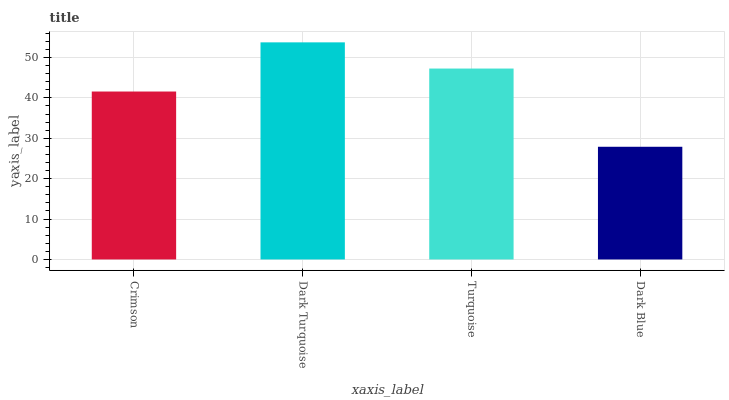Is Dark Blue the minimum?
Answer yes or no. Yes. Is Dark Turquoise the maximum?
Answer yes or no. Yes. Is Turquoise the minimum?
Answer yes or no. No. Is Turquoise the maximum?
Answer yes or no. No. Is Dark Turquoise greater than Turquoise?
Answer yes or no. Yes. Is Turquoise less than Dark Turquoise?
Answer yes or no. Yes. Is Turquoise greater than Dark Turquoise?
Answer yes or no. No. Is Dark Turquoise less than Turquoise?
Answer yes or no. No. Is Turquoise the high median?
Answer yes or no. Yes. Is Crimson the low median?
Answer yes or no. Yes. Is Dark Turquoise the high median?
Answer yes or no. No. Is Dark Turquoise the low median?
Answer yes or no. No. 